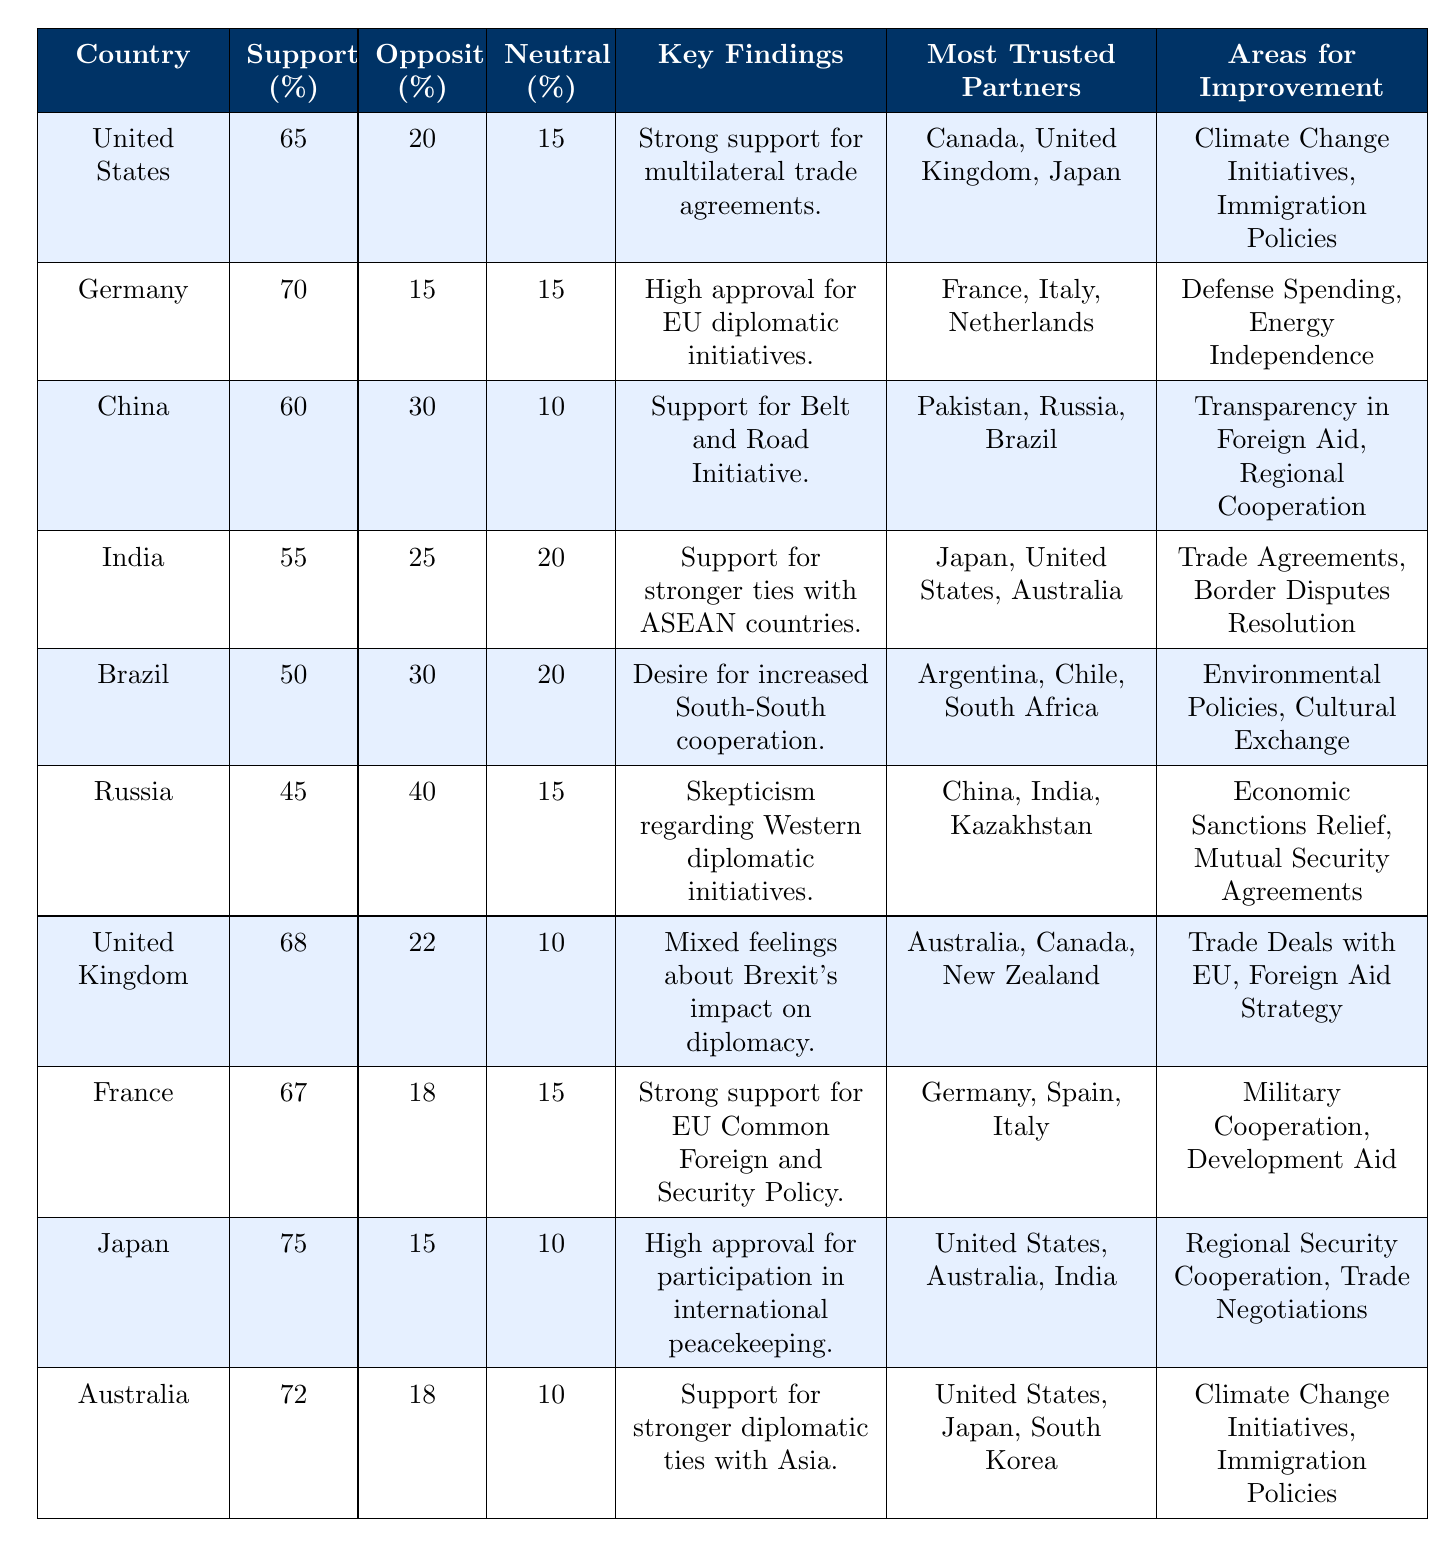What country has the highest public opinion support for foreign relations? According to the table, Japan has the highest public opinion support at 75%.
Answer: Japan What are the areas for improvement noted by Germany? The table shows that Germany's areas for improvement are Defense Spending and Energy Independence.
Answer: Defense Spending, Energy Independence Which countries have a public opinion opposition rate higher than 30%? Looking at the table, China (30%), Brazil (30%), Russia (40%) have opposition rates higher than 30%.
Answer: China, Brazil, Russia Which country has the lowest percentage of public opinion support? By reviewing the table, Russia has the lowest public opinion support at 45%.
Answer: Russia What is the average public opinion support across all countries listed? The total support is 65 + 70 + 60 + 55 + 50 + 45 + 68 + 67 + 75 + 72 =  669. There are 10 countries, thus the average is 669/10 = 66.9.
Answer: 66.9 Is the neutral opinion percentage higher in Australia or the United Kingdom? Reviewing the table, Australia has a neutral percentage of 10% while the United Kingdom also has a neutral percentage of 10%; thus both are equal.
Answer: No, they are equal Which country trusts Japan the most based on the data? The table states that Japan is trusted the most by the United States, Australia, and India. All three are mentioned as trusted partners.
Answer: United States, Australia, India What key finding is shared between China and India regarding foreign relations? Both countries emphasize strengthening ties with specific regions; China supports the Belt and Road Initiative, while India supports stronger ties with ASEAN countries.
Answer: Strengthening regional ties Which country has a higher opposition to foreign relations, Brazil or Germany? Brazil has an opposition of 30% while Germany has an opposition of 15%, so Brazil has a higher opposition percentage.
Answer: Brazil If you combine the most trusted partners of Germany and France, what countries are mentioned? Germany's trusted partners are France, Italy, and Netherlands; France’s are Germany, Spain, and Italy. Combining these lists without duplication gives: France, Italy, Netherlands, Spain.
Answer: France, Italy, Netherlands, Spain 